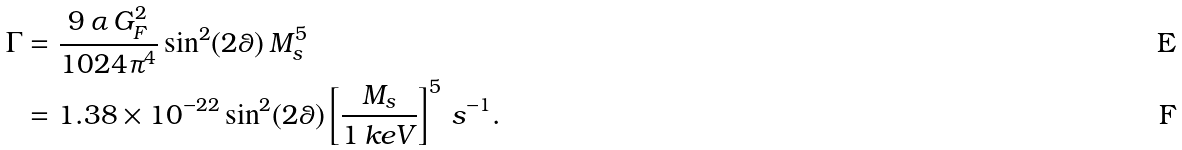<formula> <loc_0><loc_0><loc_500><loc_500>\Gamma & = \frac { 9 \, \alpha \, G _ { F } ^ { 2 } } { 1 0 2 4 \pi ^ { 4 } } \sin ^ { 2 } ( 2 \theta ) \, M _ { s } ^ { 5 } \\ & = 1 . 3 8 \times 1 0 ^ { - 2 2 } \sin ^ { 2 } ( 2 \theta ) \left [ \frac { M _ { s } } { 1 \, k e V } \right ] ^ { 5 } \, s ^ { - 1 } .</formula> 